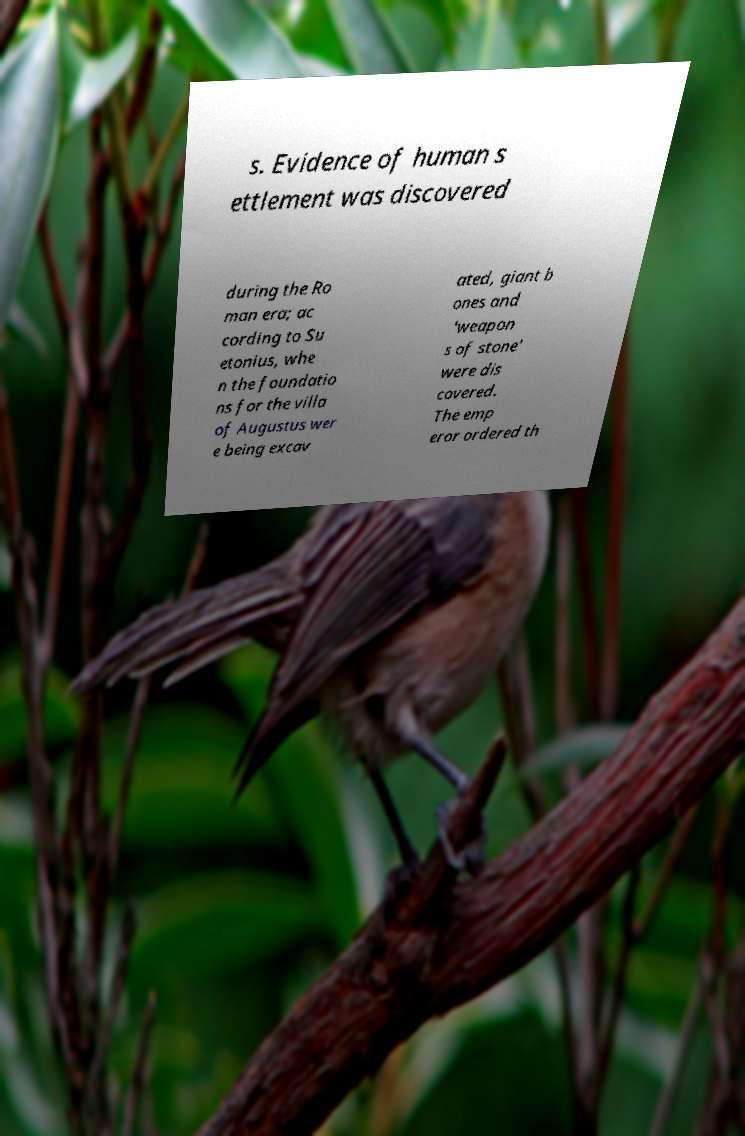Could you extract and type out the text from this image? s. Evidence of human s ettlement was discovered during the Ro man era; ac cording to Su etonius, whe n the foundatio ns for the villa of Augustus wer e being excav ated, giant b ones and 'weapon s of stone' were dis covered. The emp eror ordered th 